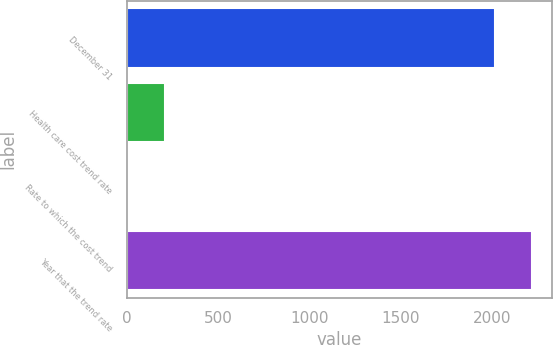Convert chart to OTSL. <chart><loc_0><loc_0><loc_500><loc_500><bar_chart><fcel>December 31<fcel>Health care cost trend rate<fcel>Rate to which the cost trend<fcel>Year that the trend rate<nl><fcel>2014<fcel>206.84<fcel>4.6<fcel>2216.24<nl></chart> 